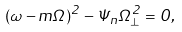<formula> <loc_0><loc_0><loc_500><loc_500>( \omega - m \Omega ) ^ { 2 } - \Psi _ { n } \Omega _ { \bot } ^ { 2 } = 0 ,</formula> 